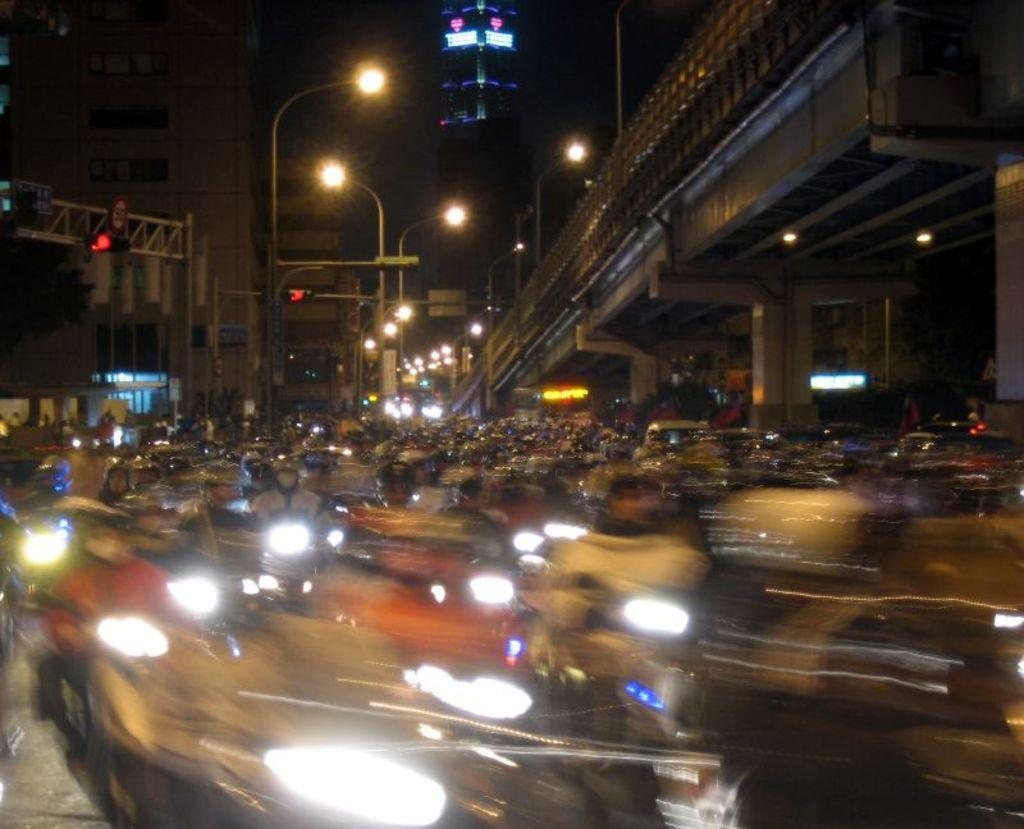What can be seen on the road in the image? There are vehicles and people on the road in the image. What is visible in the background of the image? In the background, there are lights, a bridge, buildings, traffic lights, and poles. Are there any electronic devices visible in the image? Yes, there are screens visible in the image. Can you see any kittens playing near the gate in the image? There is no gate or kittens present in the image. What is the level of fear experienced by the people on the road in the image? The image does not provide any information about the emotions or feelings of the people on the road, so it is impossible to determine their level of fear. 